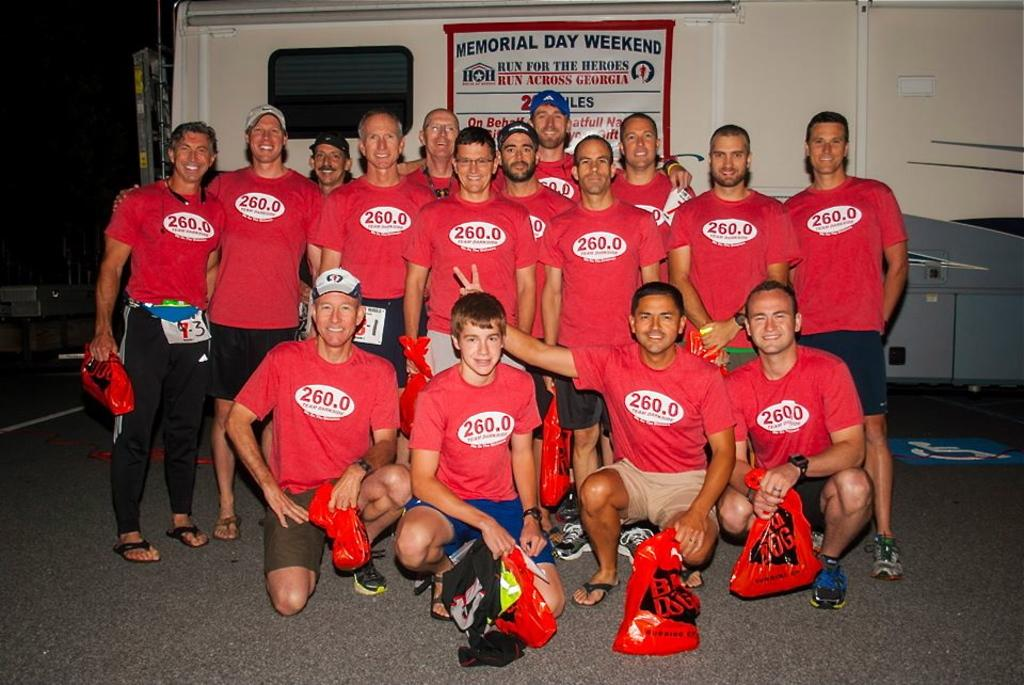How many people are in the image? There are people in the image, but the exact number is not specified. What are some of the people doing in the image? Some people are carrying objects in the image. What else can be seen in the image besides people? There is a vehicle visible in the image. What is written or displayed on the vehicle? There is text on the vehicle. What type of music can be heard coming from the vehicle in the image? There is no indication of music or any sounds in the image, so it's not possible to determine what, if any, music might be heard. 